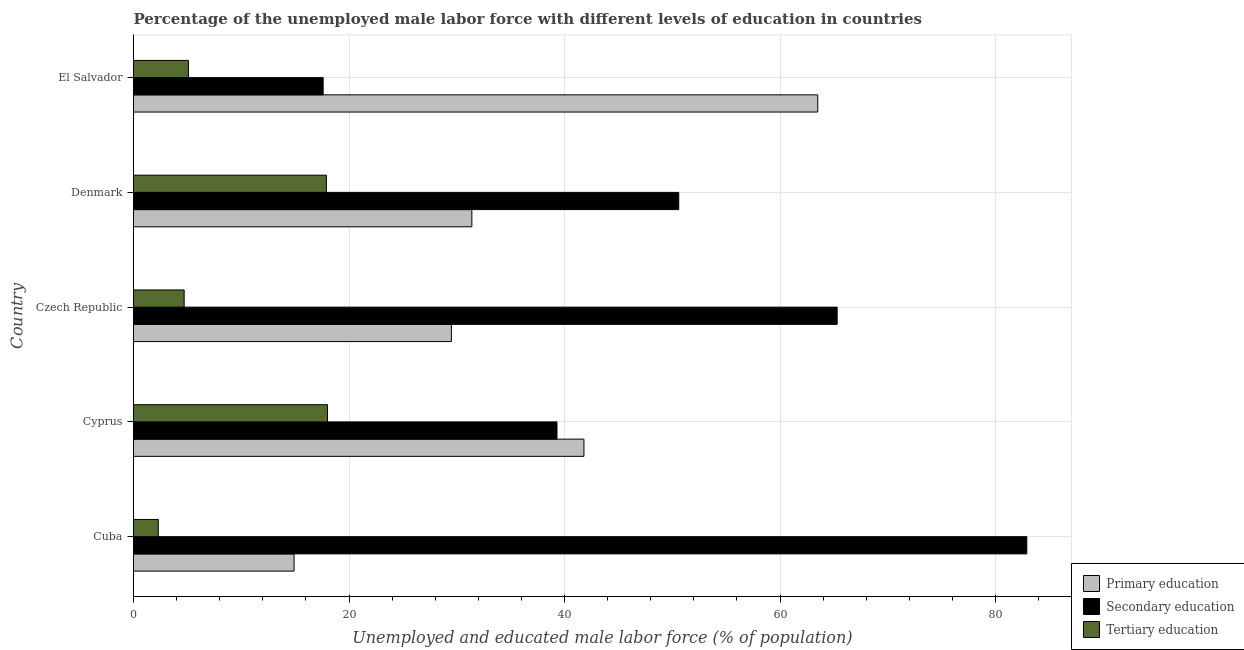How many different coloured bars are there?
Make the answer very short. 3. How many groups of bars are there?
Offer a terse response. 5. What is the label of the 4th group of bars from the top?
Your answer should be very brief. Cyprus. What is the percentage of male labor force who received primary education in Cuba?
Your answer should be very brief. 14.9. Across all countries, what is the maximum percentage of male labor force who received primary education?
Keep it short and to the point. 63.5. Across all countries, what is the minimum percentage of male labor force who received primary education?
Offer a very short reply. 14.9. In which country was the percentage of male labor force who received primary education maximum?
Make the answer very short. El Salvador. In which country was the percentage of male labor force who received tertiary education minimum?
Provide a succinct answer. Cuba. What is the total percentage of male labor force who received tertiary education in the graph?
Provide a short and direct response. 48. What is the difference between the percentage of male labor force who received tertiary education in Cuba and that in El Salvador?
Give a very brief answer. -2.8. What is the difference between the percentage of male labor force who received tertiary education in Cuba and the percentage of male labor force who received secondary education in Denmark?
Offer a very short reply. -48.3. What is the average percentage of male labor force who received secondary education per country?
Provide a succinct answer. 51.14. What is the ratio of the percentage of male labor force who received primary education in Czech Republic to that in El Salvador?
Provide a succinct answer. 0.47. Is the percentage of male labor force who received primary education in Cuba less than that in Czech Republic?
Give a very brief answer. Yes. Is the difference between the percentage of male labor force who received secondary education in Cyprus and Czech Republic greater than the difference between the percentage of male labor force who received primary education in Cyprus and Czech Republic?
Make the answer very short. No. What is the difference between the highest and the second highest percentage of male labor force who received primary education?
Offer a very short reply. 21.7. What is the difference between the highest and the lowest percentage of male labor force who received tertiary education?
Your answer should be very brief. 15.7. In how many countries, is the percentage of male labor force who received tertiary education greater than the average percentage of male labor force who received tertiary education taken over all countries?
Keep it short and to the point. 2. Is the sum of the percentage of male labor force who received tertiary education in Cyprus and El Salvador greater than the maximum percentage of male labor force who received secondary education across all countries?
Your answer should be very brief. No. What does the 1st bar from the top in Denmark represents?
Provide a short and direct response. Tertiary education. What does the 1st bar from the bottom in Cuba represents?
Offer a very short reply. Primary education. Is it the case that in every country, the sum of the percentage of male labor force who received primary education and percentage of male labor force who received secondary education is greater than the percentage of male labor force who received tertiary education?
Keep it short and to the point. Yes. How many bars are there?
Ensure brevity in your answer.  15. Are all the bars in the graph horizontal?
Ensure brevity in your answer.  Yes. What is the difference between two consecutive major ticks on the X-axis?
Your answer should be very brief. 20. Does the graph contain any zero values?
Your answer should be compact. No. Does the graph contain grids?
Provide a short and direct response. Yes. What is the title of the graph?
Keep it short and to the point. Percentage of the unemployed male labor force with different levels of education in countries. What is the label or title of the X-axis?
Make the answer very short. Unemployed and educated male labor force (% of population). What is the Unemployed and educated male labor force (% of population) of Primary education in Cuba?
Your answer should be compact. 14.9. What is the Unemployed and educated male labor force (% of population) in Secondary education in Cuba?
Your response must be concise. 82.9. What is the Unemployed and educated male labor force (% of population) in Tertiary education in Cuba?
Your answer should be compact. 2.3. What is the Unemployed and educated male labor force (% of population) of Primary education in Cyprus?
Keep it short and to the point. 41.8. What is the Unemployed and educated male labor force (% of population) in Secondary education in Cyprus?
Ensure brevity in your answer.  39.3. What is the Unemployed and educated male labor force (% of population) of Primary education in Czech Republic?
Your answer should be very brief. 29.5. What is the Unemployed and educated male labor force (% of population) in Secondary education in Czech Republic?
Offer a very short reply. 65.3. What is the Unemployed and educated male labor force (% of population) in Tertiary education in Czech Republic?
Your response must be concise. 4.7. What is the Unemployed and educated male labor force (% of population) of Primary education in Denmark?
Your answer should be very brief. 31.4. What is the Unemployed and educated male labor force (% of population) in Secondary education in Denmark?
Provide a succinct answer. 50.6. What is the Unemployed and educated male labor force (% of population) in Tertiary education in Denmark?
Your response must be concise. 17.9. What is the Unemployed and educated male labor force (% of population) in Primary education in El Salvador?
Keep it short and to the point. 63.5. What is the Unemployed and educated male labor force (% of population) of Secondary education in El Salvador?
Ensure brevity in your answer.  17.6. What is the Unemployed and educated male labor force (% of population) in Tertiary education in El Salvador?
Keep it short and to the point. 5.1. Across all countries, what is the maximum Unemployed and educated male labor force (% of population) in Primary education?
Your answer should be compact. 63.5. Across all countries, what is the maximum Unemployed and educated male labor force (% of population) of Secondary education?
Provide a succinct answer. 82.9. Across all countries, what is the maximum Unemployed and educated male labor force (% of population) in Tertiary education?
Offer a terse response. 18. Across all countries, what is the minimum Unemployed and educated male labor force (% of population) in Primary education?
Offer a terse response. 14.9. Across all countries, what is the minimum Unemployed and educated male labor force (% of population) of Secondary education?
Give a very brief answer. 17.6. Across all countries, what is the minimum Unemployed and educated male labor force (% of population) of Tertiary education?
Ensure brevity in your answer.  2.3. What is the total Unemployed and educated male labor force (% of population) in Primary education in the graph?
Make the answer very short. 181.1. What is the total Unemployed and educated male labor force (% of population) in Secondary education in the graph?
Give a very brief answer. 255.7. What is the difference between the Unemployed and educated male labor force (% of population) of Primary education in Cuba and that in Cyprus?
Provide a short and direct response. -26.9. What is the difference between the Unemployed and educated male labor force (% of population) of Secondary education in Cuba and that in Cyprus?
Ensure brevity in your answer.  43.6. What is the difference between the Unemployed and educated male labor force (% of population) in Tertiary education in Cuba and that in Cyprus?
Make the answer very short. -15.7. What is the difference between the Unemployed and educated male labor force (% of population) of Primary education in Cuba and that in Czech Republic?
Provide a succinct answer. -14.6. What is the difference between the Unemployed and educated male labor force (% of population) in Tertiary education in Cuba and that in Czech Republic?
Your answer should be compact. -2.4. What is the difference between the Unemployed and educated male labor force (% of population) of Primary education in Cuba and that in Denmark?
Keep it short and to the point. -16.5. What is the difference between the Unemployed and educated male labor force (% of population) in Secondary education in Cuba and that in Denmark?
Your response must be concise. 32.3. What is the difference between the Unemployed and educated male labor force (% of population) of Tertiary education in Cuba and that in Denmark?
Ensure brevity in your answer.  -15.6. What is the difference between the Unemployed and educated male labor force (% of population) of Primary education in Cuba and that in El Salvador?
Ensure brevity in your answer.  -48.6. What is the difference between the Unemployed and educated male labor force (% of population) in Secondary education in Cuba and that in El Salvador?
Make the answer very short. 65.3. What is the difference between the Unemployed and educated male labor force (% of population) in Tertiary education in Cuba and that in El Salvador?
Your answer should be compact. -2.8. What is the difference between the Unemployed and educated male labor force (% of population) in Primary education in Cyprus and that in Denmark?
Offer a terse response. 10.4. What is the difference between the Unemployed and educated male labor force (% of population) in Tertiary education in Cyprus and that in Denmark?
Offer a terse response. 0.1. What is the difference between the Unemployed and educated male labor force (% of population) of Primary education in Cyprus and that in El Salvador?
Make the answer very short. -21.7. What is the difference between the Unemployed and educated male labor force (% of population) of Secondary education in Cyprus and that in El Salvador?
Ensure brevity in your answer.  21.7. What is the difference between the Unemployed and educated male labor force (% of population) in Secondary education in Czech Republic and that in Denmark?
Your answer should be very brief. 14.7. What is the difference between the Unemployed and educated male labor force (% of population) in Tertiary education in Czech Republic and that in Denmark?
Give a very brief answer. -13.2. What is the difference between the Unemployed and educated male labor force (% of population) in Primary education in Czech Republic and that in El Salvador?
Offer a very short reply. -34. What is the difference between the Unemployed and educated male labor force (% of population) in Secondary education in Czech Republic and that in El Salvador?
Give a very brief answer. 47.7. What is the difference between the Unemployed and educated male labor force (% of population) in Primary education in Denmark and that in El Salvador?
Make the answer very short. -32.1. What is the difference between the Unemployed and educated male labor force (% of population) in Primary education in Cuba and the Unemployed and educated male labor force (% of population) in Secondary education in Cyprus?
Provide a short and direct response. -24.4. What is the difference between the Unemployed and educated male labor force (% of population) in Primary education in Cuba and the Unemployed and educated male labor force (% of population) in Tertiary education in Cyprus?
Provide a succinct answer. -3.1. What is the difference between the Unemployed and educated male labor force (% of population) in Secondary education in Cuba and the Unemployed and educated male labor force (% of population) in Tertiary education in Cyprus?
Make the answer very short. 64.9. What is the difference between the Unemployed and educated male labor force (% of population) of Primary education in Cuba and the Unemployed and educated male labor force (% of population) of Secondary education in Czech Republic?
Ensure brevity in your answer.  -50.4. What is the difference between the Unemployed and educated male labor force (% of population) in Primary education in Cuba and the Unemployed and educated male labor force (% of population) in Tertiary education in Czech Republic?
Ensure brevity in your answer.  10.2. What is the difference between the Unemployed and educated male labor force (% of population) in Secondary education in Cuba and the Unemployed and educated male labor force (% of population) in Tertiary education in Czech Republic?
Offer a terse response. 78.2. What is the difference between the Unemployed and educated male labor force (% of population) of Primary education in Cuba and the Unemployed and educated male labor force (% of population) of Secondary education in Denmark?
Offer a very short reply. -35.7. What is the difference between the Unemployed and educated male labor force (% of population) of Primary education in Cuba and the Unemployed and educated male labor force (% of population) of Tertiary education in El Salvador?
Your answer should be very brief. 9.8. What is the difference between the Unemployed and educated male labor force (% of population) of Secondary education in Cuba and the Unemployed and educated male labor force (% of population) of Tertiary education in El Salvador?
Your response must be concise. 77.8. What is the difference between the Unemployed and educated male labor force (% of population) in Primary education in Cyprus and the Unemployed and educated male labor force (% of population) in Secondary education in Czech Republic?
Provide a succinct answer. -23.5. What is the difference between the Unemployed and educated male labor force (% of population) of Primary education in Cyprus and the Unemployed and educated male labor force (% of population) of Tertiary education in Czech Republic?
Your answer should be compact. 37.1. What is the difference between the Unemployed and educated male labor force (% of population) of Secondary education in Cyprus and the Unemployed and educated male labor force (% of population) of Tertiary education in Czech Republic?
Make the answer very short. 34.6. What is the difference between the Unemployed and educated male labor force (% of population) in Primary education in Cyprus and the Unemployed and educated male labor force (% of population) in Tertiary education in Denmark?
Provide a short and direct response. 23.9. What is the difference between the Unemployed and educated male labor force (% of population) in Secondary education in Cyprus and the Unemployed and educated male labor force (% of population) in Tertiary education in Denmark?
Keep it short and to the point. 21.4. What is the difference between the Unemployed and educated male labor force (% of population) of Primary education in Cyprus and the Unemployed and educated male labor force (% of population) of Secondary education in El Salvador?
Provide a short and direct response. 24.2. What is the difference between the Unemployed and educated male labor force (% of population) of Primary education in Cyprus and the Unemployed and educated male labor force (% of population) of Tertiary education in El Salvador?
Provide a short and direct response. 36.7. What is the difference between the Unemployed and educated male labor force (% of population) in Secondary education in Cyprus and the Unemployed and educated male labor force (% of population) in Tertiary education in El Salvador?
Offer a terse response. 34.2. What is the difference between the Unemployed and educated male labor force (% of population) in Primary education in Czech Republic and the Unemployed and educated male labor force (% of population) in Secondary education in Denmark?
Your answer should be compact. -21.1. What is the difference between the Unemployed and educated male labor force (% of population) of Primary education in Czech Republic and the Unemployed and educated male labor force (% of population) of Tertiary education in Denmark?
Offer a terse response. 11.6. What is the difference between the Unemployed and educated male labor force (% of population) of Secondary education in Czech Republic and the Unemployed and educated male labor force (% of population) of Tertiary education in Denmark?
Provide a short and direct response. 47.4. What is the difference between the Unemployed and educated male labor force (% of population) of Primary education in Czech Republic and the Unemployed and educated male labor force (% of population) of Tertiary education in El Salvador?
Make the answer very short. 24.4. What is the difference between the Unemployed and educated male labor force (% of population) in Secondary education in Czech Republic and the Unemployed and educated male labor force (% of population) in Tertiary education in El Salvador?
Ensure brevity in your answer.  60.2. What is the difference between the Unemployed and educated male labor force (% of population) of Primary education in Denmark and the Unemployed and educated male labor force (% of population) of Tertiary education in El Salvador?
Ensure brevity in your answer.  26.3. What is the difference between the Unemployed and educated male labor force (% of population) in Secondary education in Denmark and the Unemployed and educated male labor force (% of population) in Tertiary education in El Salvador?
Provide a short and direct response. 45.5. What is the average Unemployed and educated male labor force (% of population) in Primary education per country?
Provide a succinct answer. 36.22. What is the average Unemployed and educated male labor force (% of population) in Secondary education per country?
Provide a short and direct response. 51.14. What is the difference between the Unemployed and educated male labor force (% of population) in Primary education and Unemployed and educated male labor force (% of population) in Secondary education in Cuba?
Offer a terse response. -68. What is the difference between the Unemployed and educated male labor force (% of population) of Secondary education and Unemployed and educated male labor force (% of population) of Tertiary education in Cuba?
Provide a short and direct response. 80.6. What is the difference between the Unemployed and educated male labor force (% of population) in Primary education and Unemployed and educated male labor force (% of population) in Secondary education in Cyprus?
Your answer should be very brief. 2.5. What is the difference between the Unemployed and educated male labor force (% of population) in Primary education and Unemployed and educated male labor force (% of population) in Tertiary education in Cyprus?
Your response must be concise. 23.8. What is the difference between the Unemployed and educated male labor force (% of population) of Secondary education and Unemployed and educated male labor force (% of population) of Tertiary education in Cyprus?
Keep it short and to the point. 21.3. What is the difference between the Unemployed and educated male labor force (% of population) of Primary education and Unemployed and educated male labor force (% of population) of Secondary education in Czech Republic?
Make the answer very short. -35.8. What is the difference between the Unemployed and educated male labor force (% of population) of Primary education and Unemployed and educated male labor force (% of population) of Tertiary education in Czech Republic?
Offer a very short reply. 24.8. What is the difference between the Unemployed and educated male labor force (% of population) of Secondary education and Unemployed and educated male labor force (% of population) of Tertiary education in Czech Republic?
Your response must be concise. 60.6. What is the difference between the Unemployed and educated male labor force (% of population) in Primary education and Unemployed and educated male labor force (% of population) in Secondary education in Denmark?
Provide a succinct answer. -19.2. What is the difference between the Unemployed and educated male labor force (% of population) of Primary education and Unemployed and educated male labor force (% of population) of Tertiary education in Denmark?
Your answer should be compact. 13.5. What is the difference between the Unemployed and educated male labor force (% of population) of Secondary education and Unemployed and educated male labor force (% of population) of Tertiary education in Denmark?
Your answer should be very brief. 32.7. What is the difference between the Unemployed and educated male labor force (% of population) in Primary education and Unemployed and educated male labor force (% of population) in Secondary education in El Salvador?
Make the answer very short. 45.9. What is the difference between the Unemployed and educated male labor force (% of population) of Primary education and Unemployed and educated male labor force (% of population) of Tertiary education in El Salvador?
Your response must be concise. 58.4. What is the difference between the Unemployed and educated male labor force (% of population) of Secondary education and Unemployed and educated male labor force (% of population) of Tertiary education in El Salvador?
Give a very brief answer. 12.5. What is the ratio of the Unemployed and educated male labor force (% of population) of Primary education in Cuba to that in Cyprus?
Ensure brevity in your answer.  0.36. What is the ratio of the Unemployed and educated male labor force (% of population) in Secondary education in Cuba to that in Cyprus?
Your response must be concise. 2.11. What is the ratio of the Unemployed and educated male labor force (% of population) in Tertiary education in Cuba to that in Cyprus?
Keep it short and to the point. 0.13. What is the ratio of the Unemployed and educated male labor force (% of population) in Primary education in Cuba to that in Czech Republic?
Provide a succinct answer. 0.51. What is the ratio of the Unemployed and educated male labor force (% of population) of Secondary education in Cuba to that in Czech Republic?
Ensure brevity in your answer.  1.27. What is the ratio of the Unemployed and educated male labor force (% of population) of Tertiary education in Cuba to that in Czech Republic?
Your answer should be compact. 0.49. What is the ratio of the Unemployed and educated male labor force (% of population) in Primary education in Cuba to that in Denmark?
Ensure brevity in your answer.  0.47. What is the ratio of the Unemployed and educated male labor force (% of population) in Secondary education in Cuba to that in Denmark?
Your answer should be compact. 1.64. What is the ratio of the Unemployed and educated male labor force (% of population) in Tertiary education in Cuba to that in Denmark?
Your response must be concise. 0.13. What is the ratio of the Unemployed and educated male labor force (% of population) of Primary education in Cuba to that in El Salvador?
Your answer should be compact. 0.23. What is the ratio of the Unemployed and educated male labor force (% of population) of Secondary education in Cuba to that in El Salvador?
Offer a terse response. 4.71. What is the ratio of the Unemployed and educated male labor force (% of population) in Tertiary education in Cuba to that in El Salvador?
Provide a short and direct response. 0.45. What is the ratio of the Unemployed and educated male labor force (% of population) of Primary education in Cyprus to that in Czech Republic?
Offer a terse response. 1.42. What is the ratio of the Unemployed and educated male labor force (% of population) in Secondary education in Cyprus to that in Czech Republic?
Provide a succinct answer. 0.6. What is the ratio of the Unemployed and educated male labor force (% of population) of Tertiary education in Cyprus to that in Czech Republic?
Your response must be concise. 3.83. What is the ratio of the Unemployed and educated male labor force (% of population) of Primary education in Cyprus to that in Denmark?
Your response must be concise. 1.33. What is the ratio of the Unemployed and educated male labor force (% of population) in Secondary education in Cyprus to that in Denmark?
Your answer should be very brief. 0.78. What is the ratio of the Unemployed and educated male labor force (% of population) in Tertiary education in Cyprus to that in Denmark?
Make the answer very short. 1.01. What is the ratio of the Unemployed and educated male labor force (% of population) of Primary education in Cyprus to that in El Salvador?
Your answer should be compact. 0.66. What is the ratio of the Unemployed and educated male labor force (% of population) of Secondary education in Cyprus to that in El Salvador?
Provide a succinct answer. 2.23. What is the ratio of the Unemployed and educated male labor force (% of population) in Tertiary education in Cyprus to that in El Salvador?
Offer a terse response. 3.53. What is the ratio of the Unemployed and educated male labor force (% of population) in Primary education in Czech Republic to that in Denmark?
Offer a terse response. 0.94. What is the ratio of the Unemployed and educated male labor force (% of population) in Secondary education in Czech Republic to that in Denmark?
Keep it short and to the point. 1.29. What is the ratio of the Unemployed and educated male labor force (% of population) in Tertiary education in Czech Republic to that in Denmark?
Your answer should be compact. 0.26. What is the ratio of the Unemployed and educated male labor force (% of population) of Primary education in Czech Republic to that in El Salvador?
Your answer should be very brief. 0.46. What is the ratio of the Unemployed and educated male labor force (% of population) of Secondary education in Czech Republic to that in El Salvador?
Offer a very short reply. 3.71. What is the ratio of the Unemployed and educated male labor force (% of population) of Tertiary education in Czech Republic to that in El Salvador?
Keep it short and to the point. 0.92. What is the ratio of the Unemployed and educated male labor force (% of population) in Primary education in Denmark to that in El Salvador?
Provide a succinct answer. 0.49. What is the ratio of the Unemployed and educated male labor force (% of population) of Secondary education in Denmark to that in El Salvador?
Offer a terse response. 2.88. What is the ratio of the Unemployed and educated male labor force (% of population) in Tertiary education in Denmark to that in El Salvador?
Your response must be concise. 3.51. What is the difference between the highest and the second highest Unemployed and educated male labor force (% of population) of Primary education?
Offer a very short reply. 21.7. What is the difference between the highest and the second highest Unemployed and educated male labor force (% of population) in Tertiary education?
Your response must be concise. 0.1. What is the difference between the highest and the lowest Unemployed and educated male labor force (% of population) in Primary education?
Offer a very short reply. 48.6. What is the difference between the highest and the lowest Unemployed and educated male labor force (% of population) in Secondary education?
Your response must be concise. 65.3. 